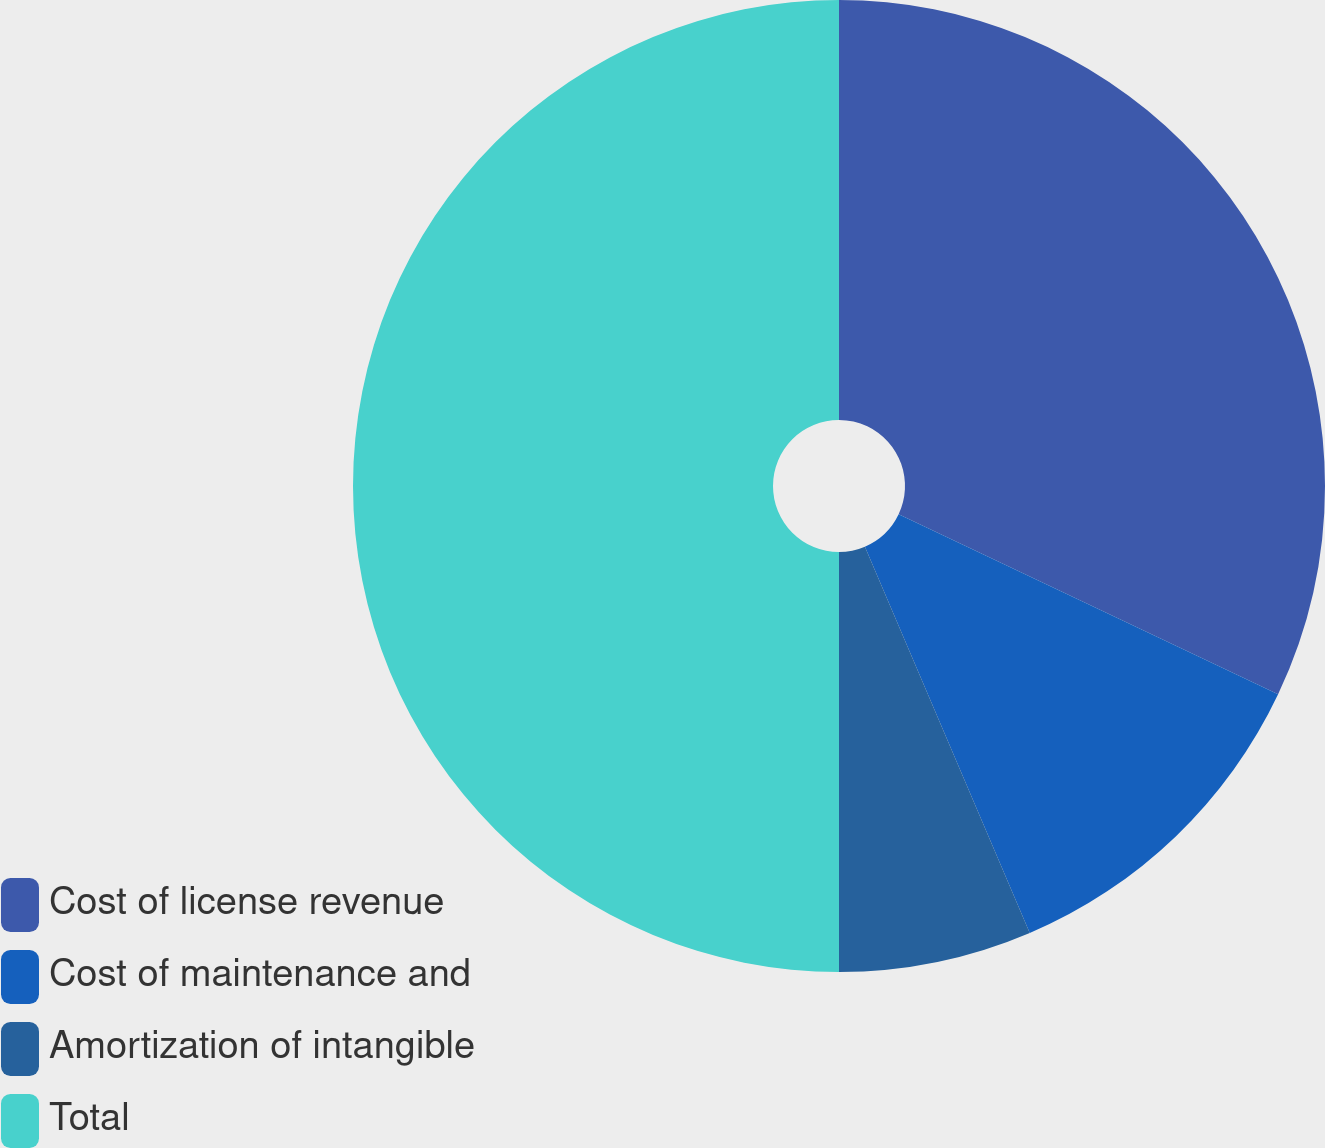Convert chart to OTSL. <chart><loc_0><loc_0><loc_500><loc_500><pie_chart><fcel>Cost of license revenue<fcel>Cost of maintenance and<fcel>Amortization of intangible<fcel>Total<nl><fcel>32.05%<fcel>11.53%<fcel>6.42%<fcel>50.0%<nl></chart> 